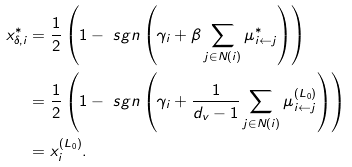<formula> <loc_0><loc_0><loc_500><loc_500>x _ { \delta , i } ^ { * } & = \frac { 1 } { 2 } \left ( 1 - \ s g n \left ( \gamma _ { i } + \beta \sum _ { j \in N ( i ) } \mu _ { i \leftarrow j } ^ { * } \right ) \right ) \\ & = \frac { 1 } { 2 } \left ( 1 - \ s g n \left ( \gamma _ { i } + \frac { 1 } { d _ { v } - 1 } \sum _ { j \in N ( i ) } \mu _ { i \leftarrow j } ^ { ( L _ { 0 } ) } \right ) \right ) \\ & = x _ { i } ^ { ( L _ { 0 } ) } .</formula> 